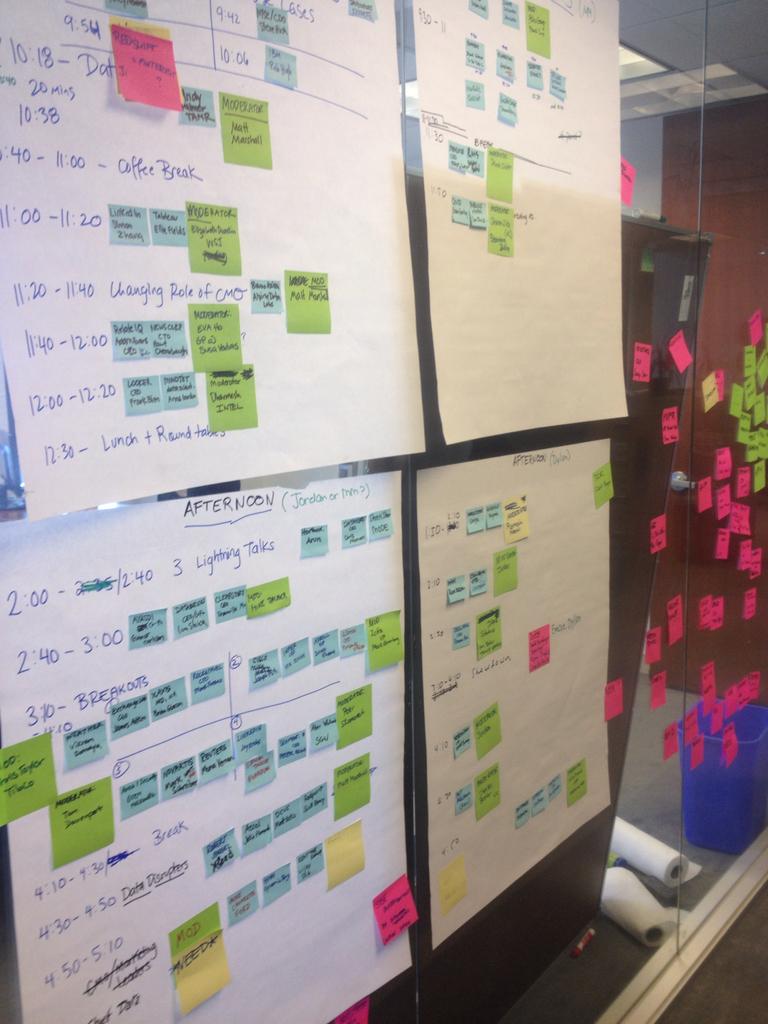What is underlined at the very top of the closest sign?
Provide a succinct answer. Afternoon. 